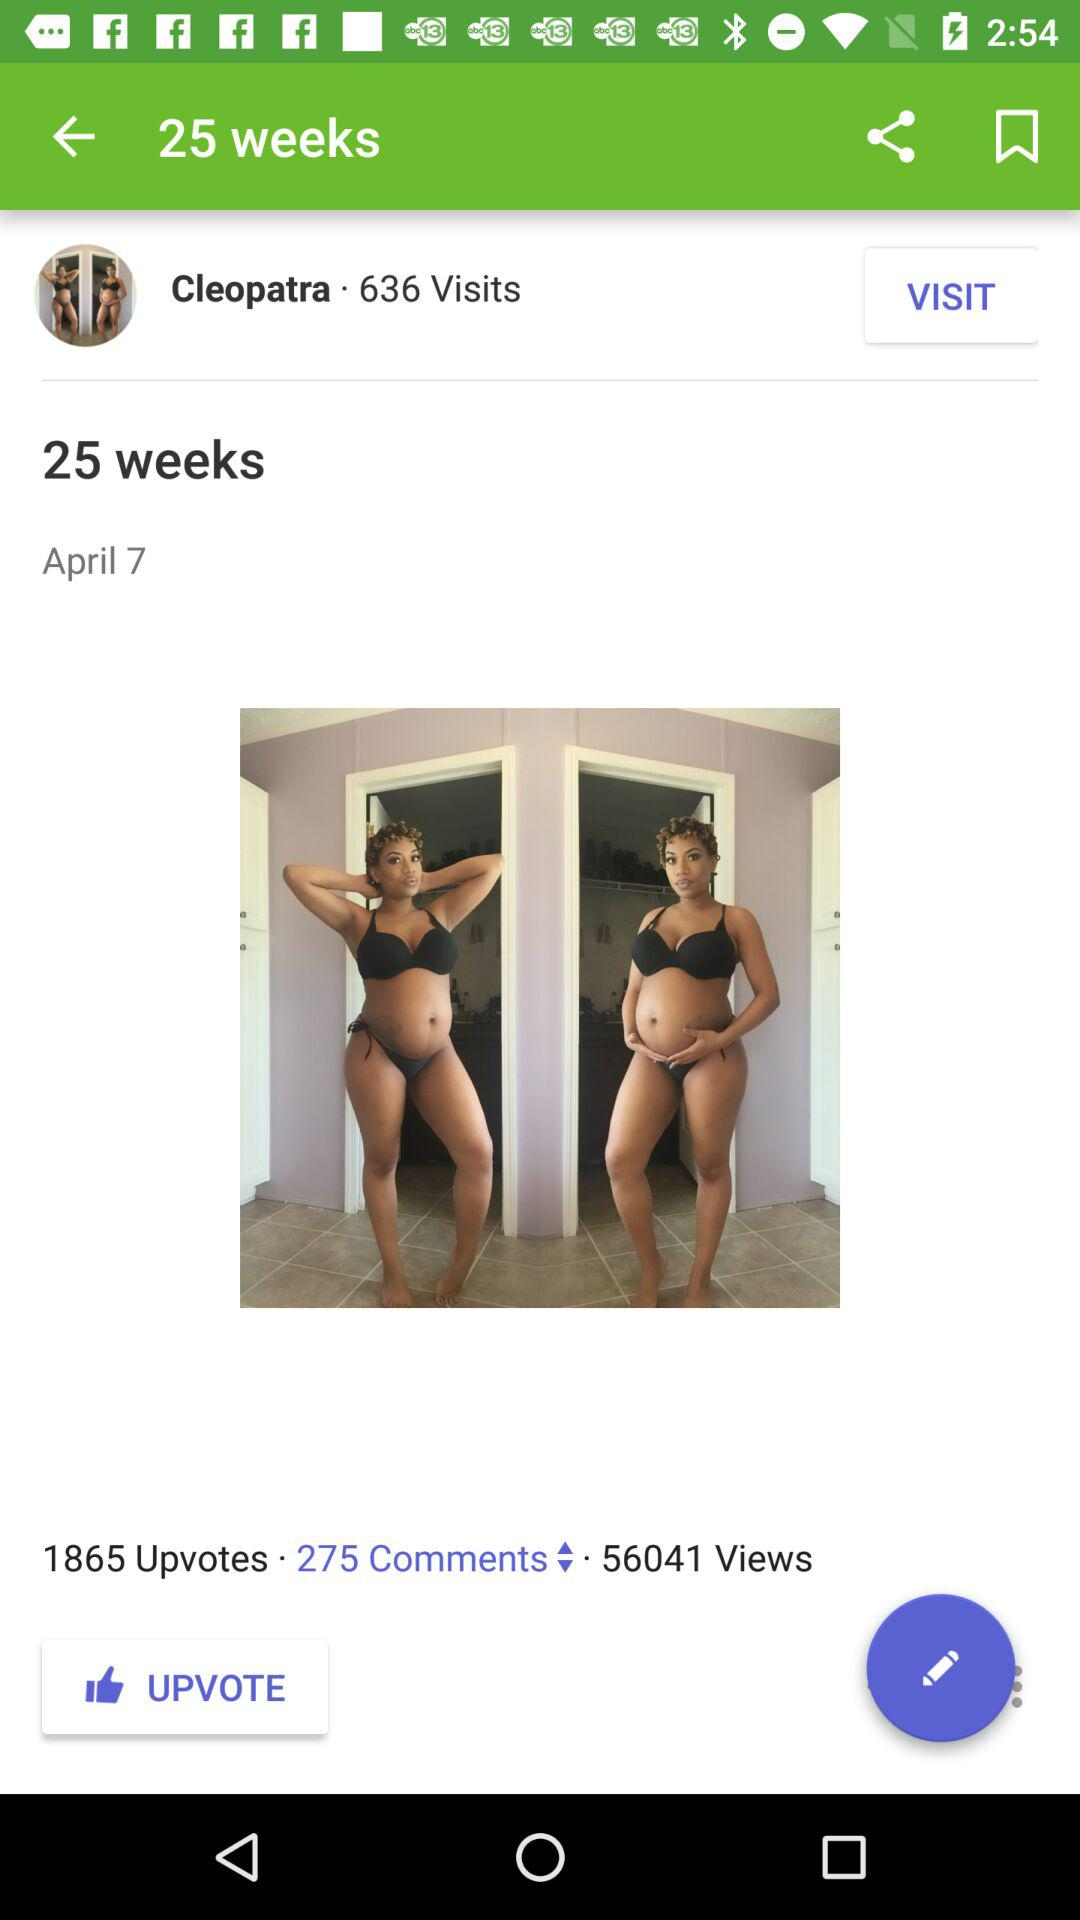What is the exact number of views? The exact number of views is 56041. 